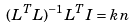Convert formula to latex. <formula><loc_0><loc_0><loc_500><loc_500>( L ^ { T } L ) ^ { - 1 } L ^ { T } I = k n</formula> 